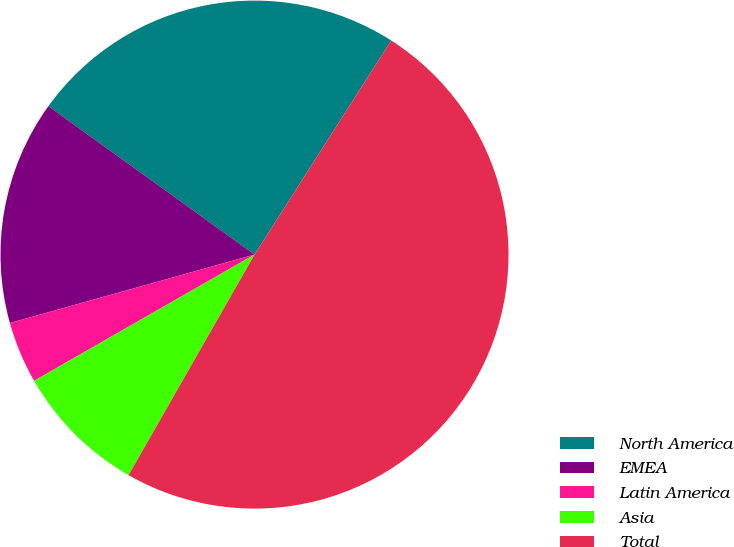Convert chart. <chart><loc_0><loc_0><loc_500><loc_500><pie_chart><fcel>North America<fcel>EMEA<fcel>Latin America<fcel>Asia<fcel>Total<nl><fcel>24.11%<fcel>14.27%<fcel>3.94%<fcel>8.46%<fcel>49.21%<nl></chart> 